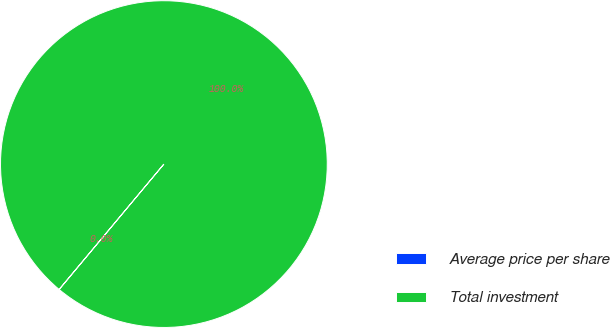Convert chart to OTSL. <chart><loc_0><loc_0><loc_500><loc_500><pie_chart><fcel>Average price per share<fcel>Total investment<nl><fcel>0.02%<fcel>99.98%<nl></chart> 